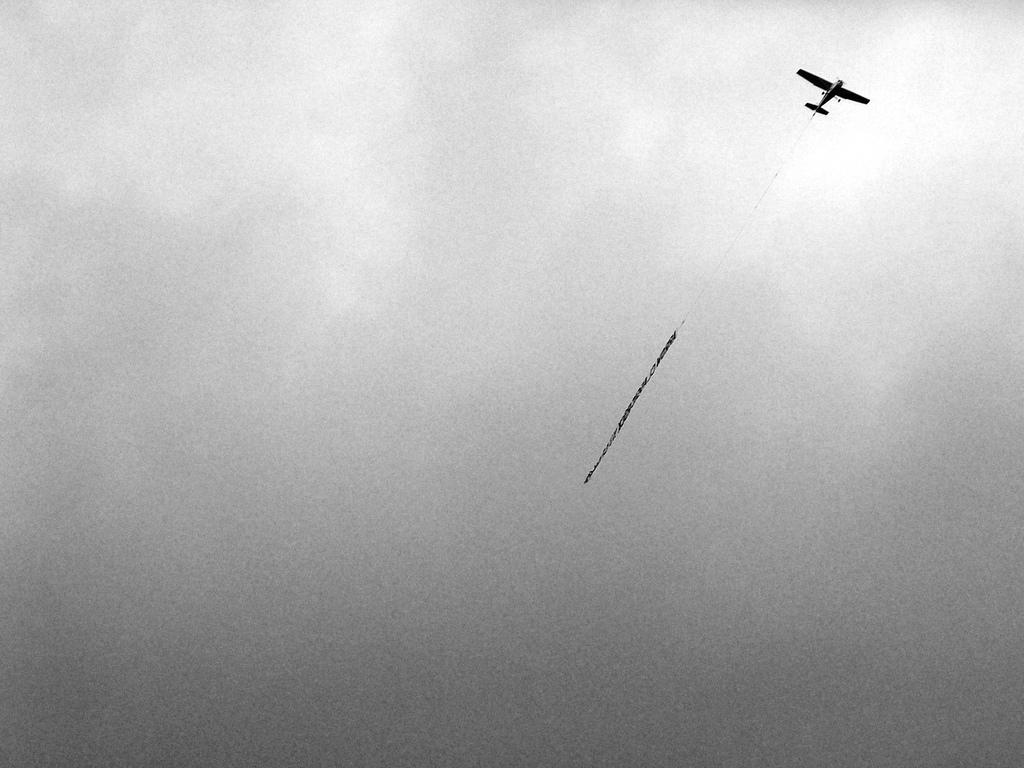What is the main subject of the image? The main subject of the image is an airplane. What can be seen in the background of the image? The sky is visible in the background of the image. Where is the nest located in the image? There is no nest present in the image. What type of flower can be seen growing near the airplane? There are no flowers present in the image. 